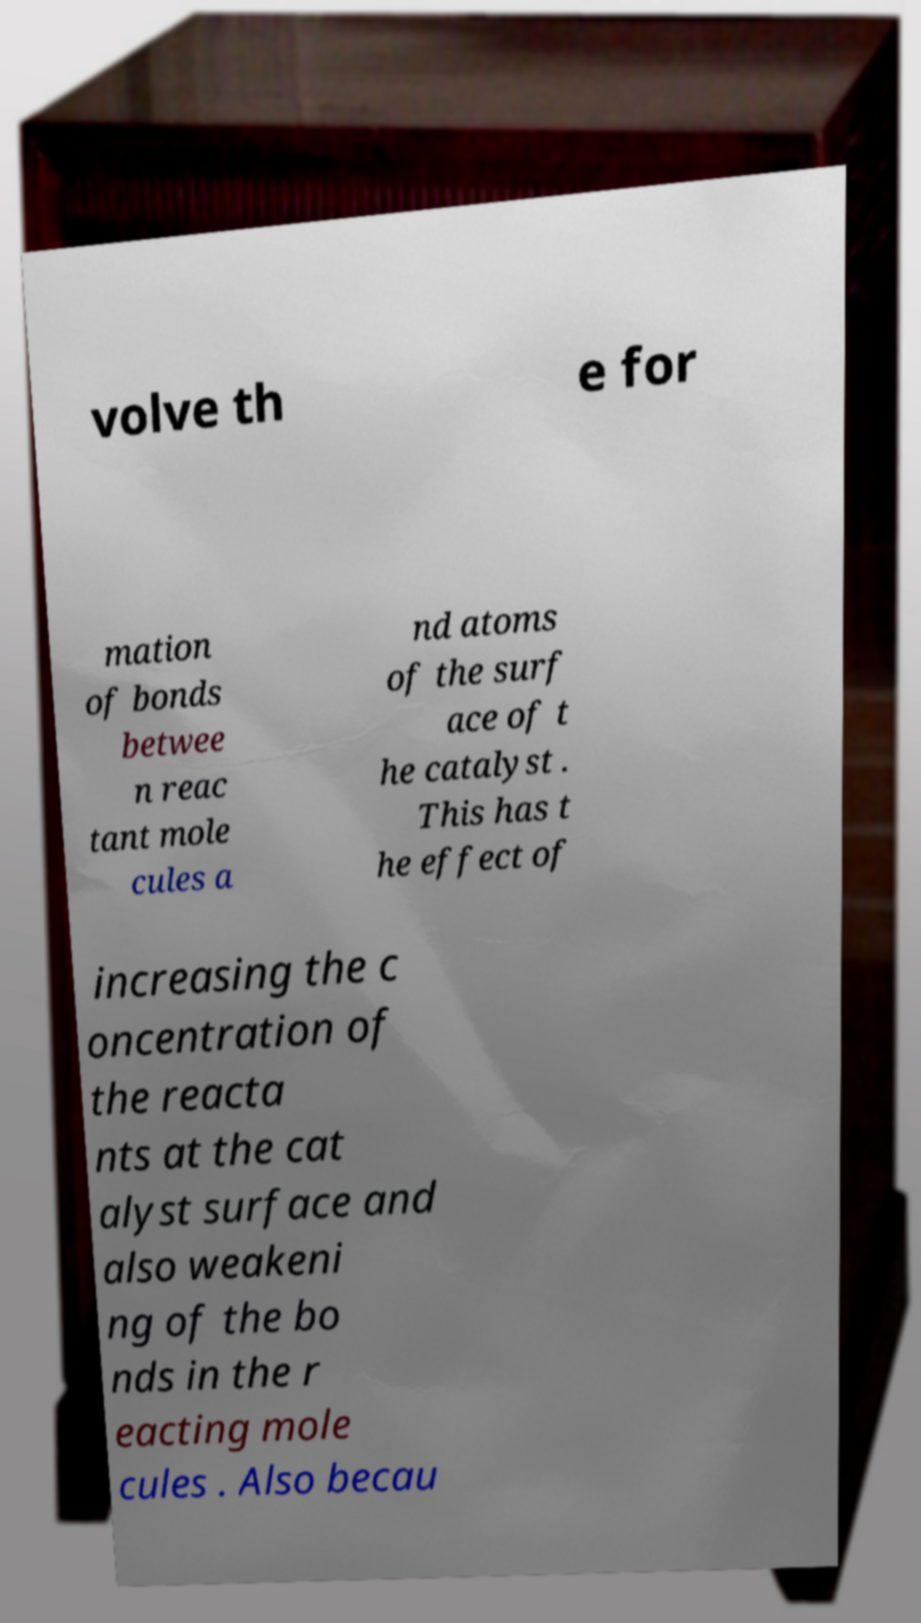Please read and relay the text visible in this image. What does it say? volve th e for mation of bonds betwee n reac tant mole cules a nd atoms of the surf ace of t he catalyst . This has t he effect of increasing the c oncentration of the reacta nts at the cat alyst surface and also weakeni ng of the bo nds in the r eacting mole cules . Also becau 